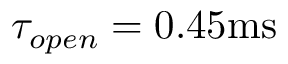Convert formula to latex. <formula><loc_0><loc_0><loc_500><loc_500>\tau _ { o p e n } = 0 . 4 5 m s</formula> 